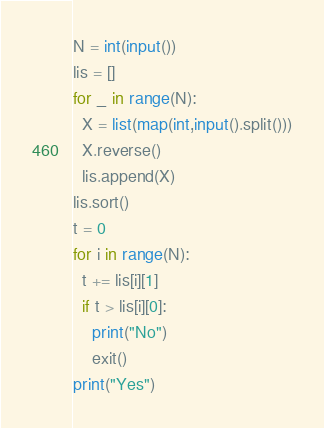Convert code to text. <code><loc_0><loc_0><loc_500><loc_500><_Python_>N = int(input())
lis = []
for _ in range(N):
  X = list(map(int,input().split()))
  X.reverse()
  lis.append(X)
lis.sort()
t = 0
for i in range(N):
  t += lis[i][1]
  if t > lis[i][0]:
    print("No")
    exit()
print("Yes")</code> 